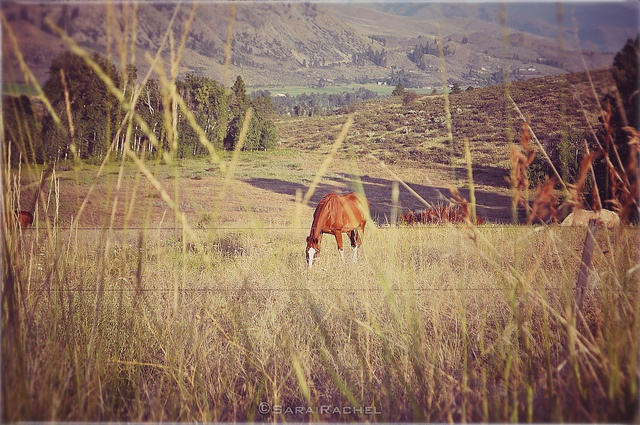Describe the objects in this image and their specific colors. I can see horse in gray, tan, salmon, and brown tones and horse in gray, maroon, black, and brown tones in this image. 